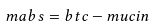<formula> <loc_0><loc_0><loc_500><loc_500>m a b s = b t c - m u c i n</formula> 